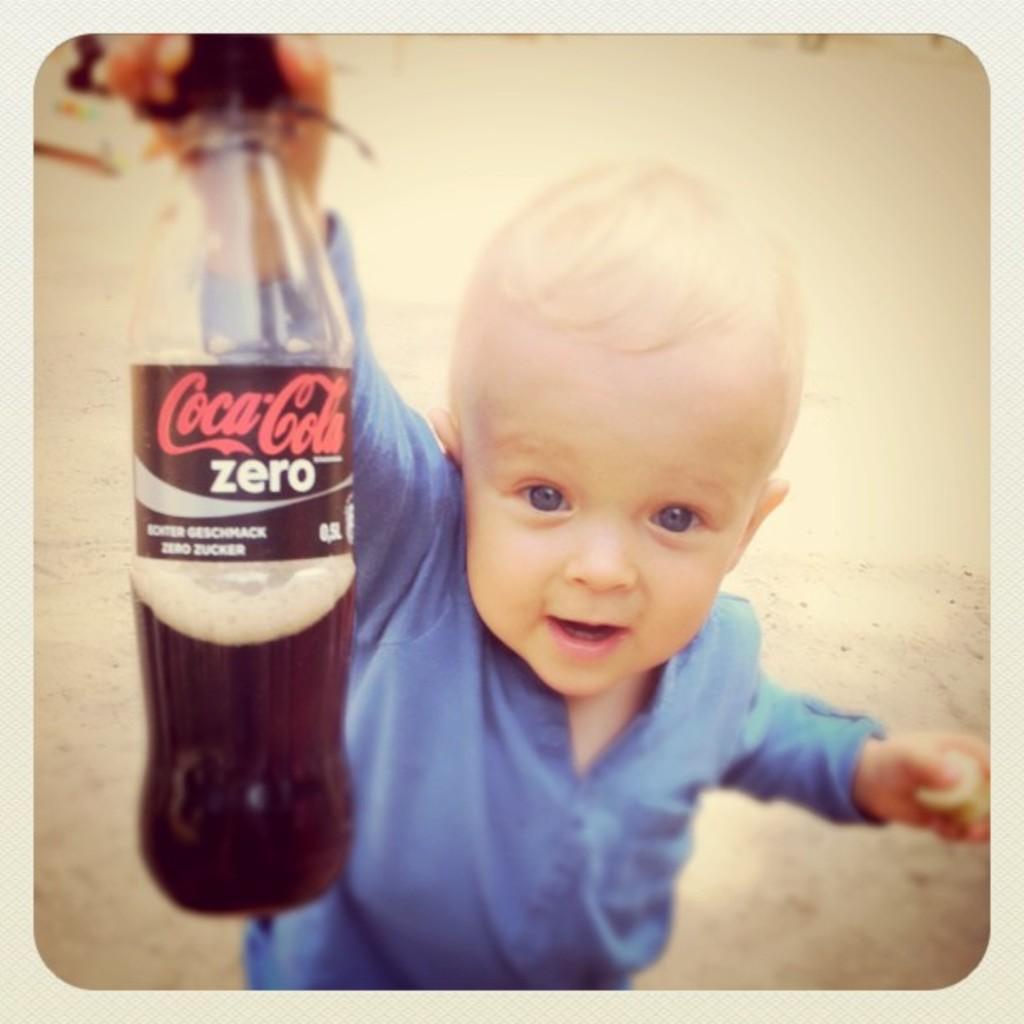Can you describe this image briefly? In this image i can see a child wearing a blue dress is holding a coca cola bottle in his hand. In the background i can see the ground. 